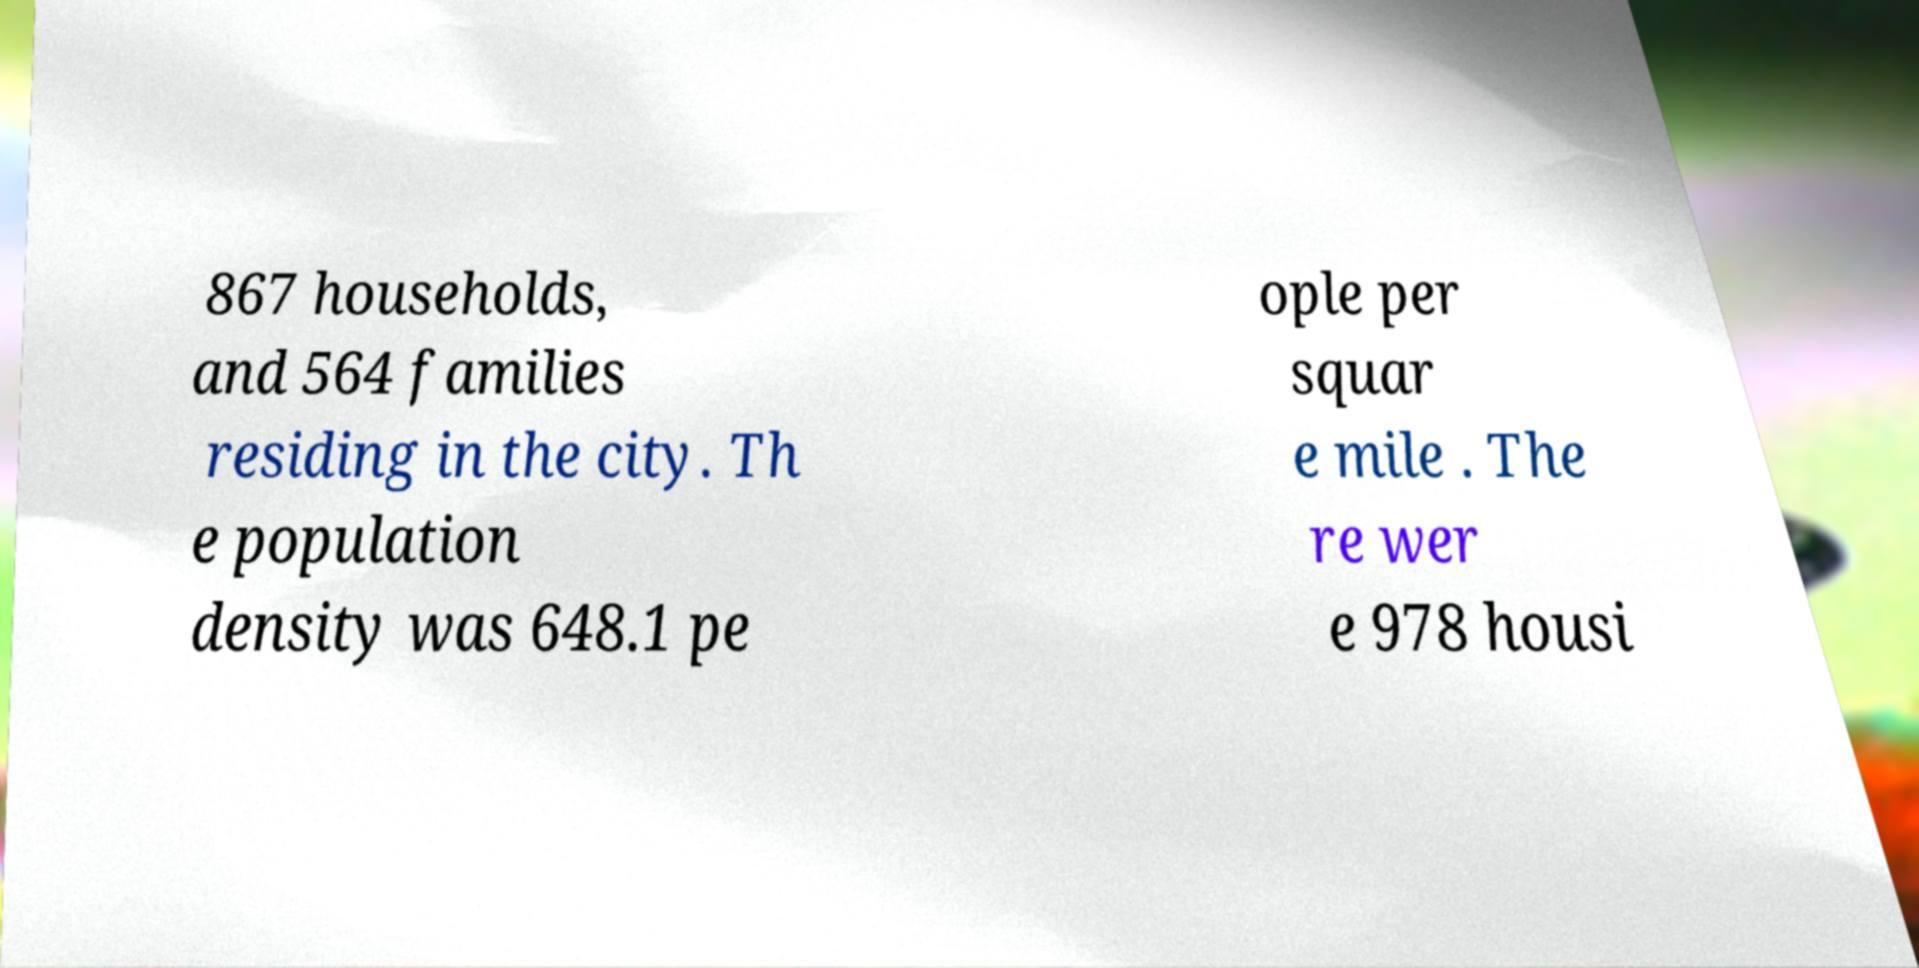I need the written content from this picture converted into text. Can you do that? 867 households, and 564 families residing in the city. Th e population density was 648.1 pe ople per squar e mile . The re wer e 978 housi 